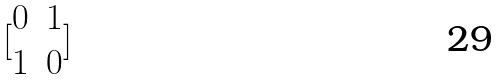Convert formula to latex. <formula><loc_0><loc_0><loc_500><loc_500>[ \begin{matrix} 0 & 1 \\ 1 & 0 \end{matrix} ]</formula> 